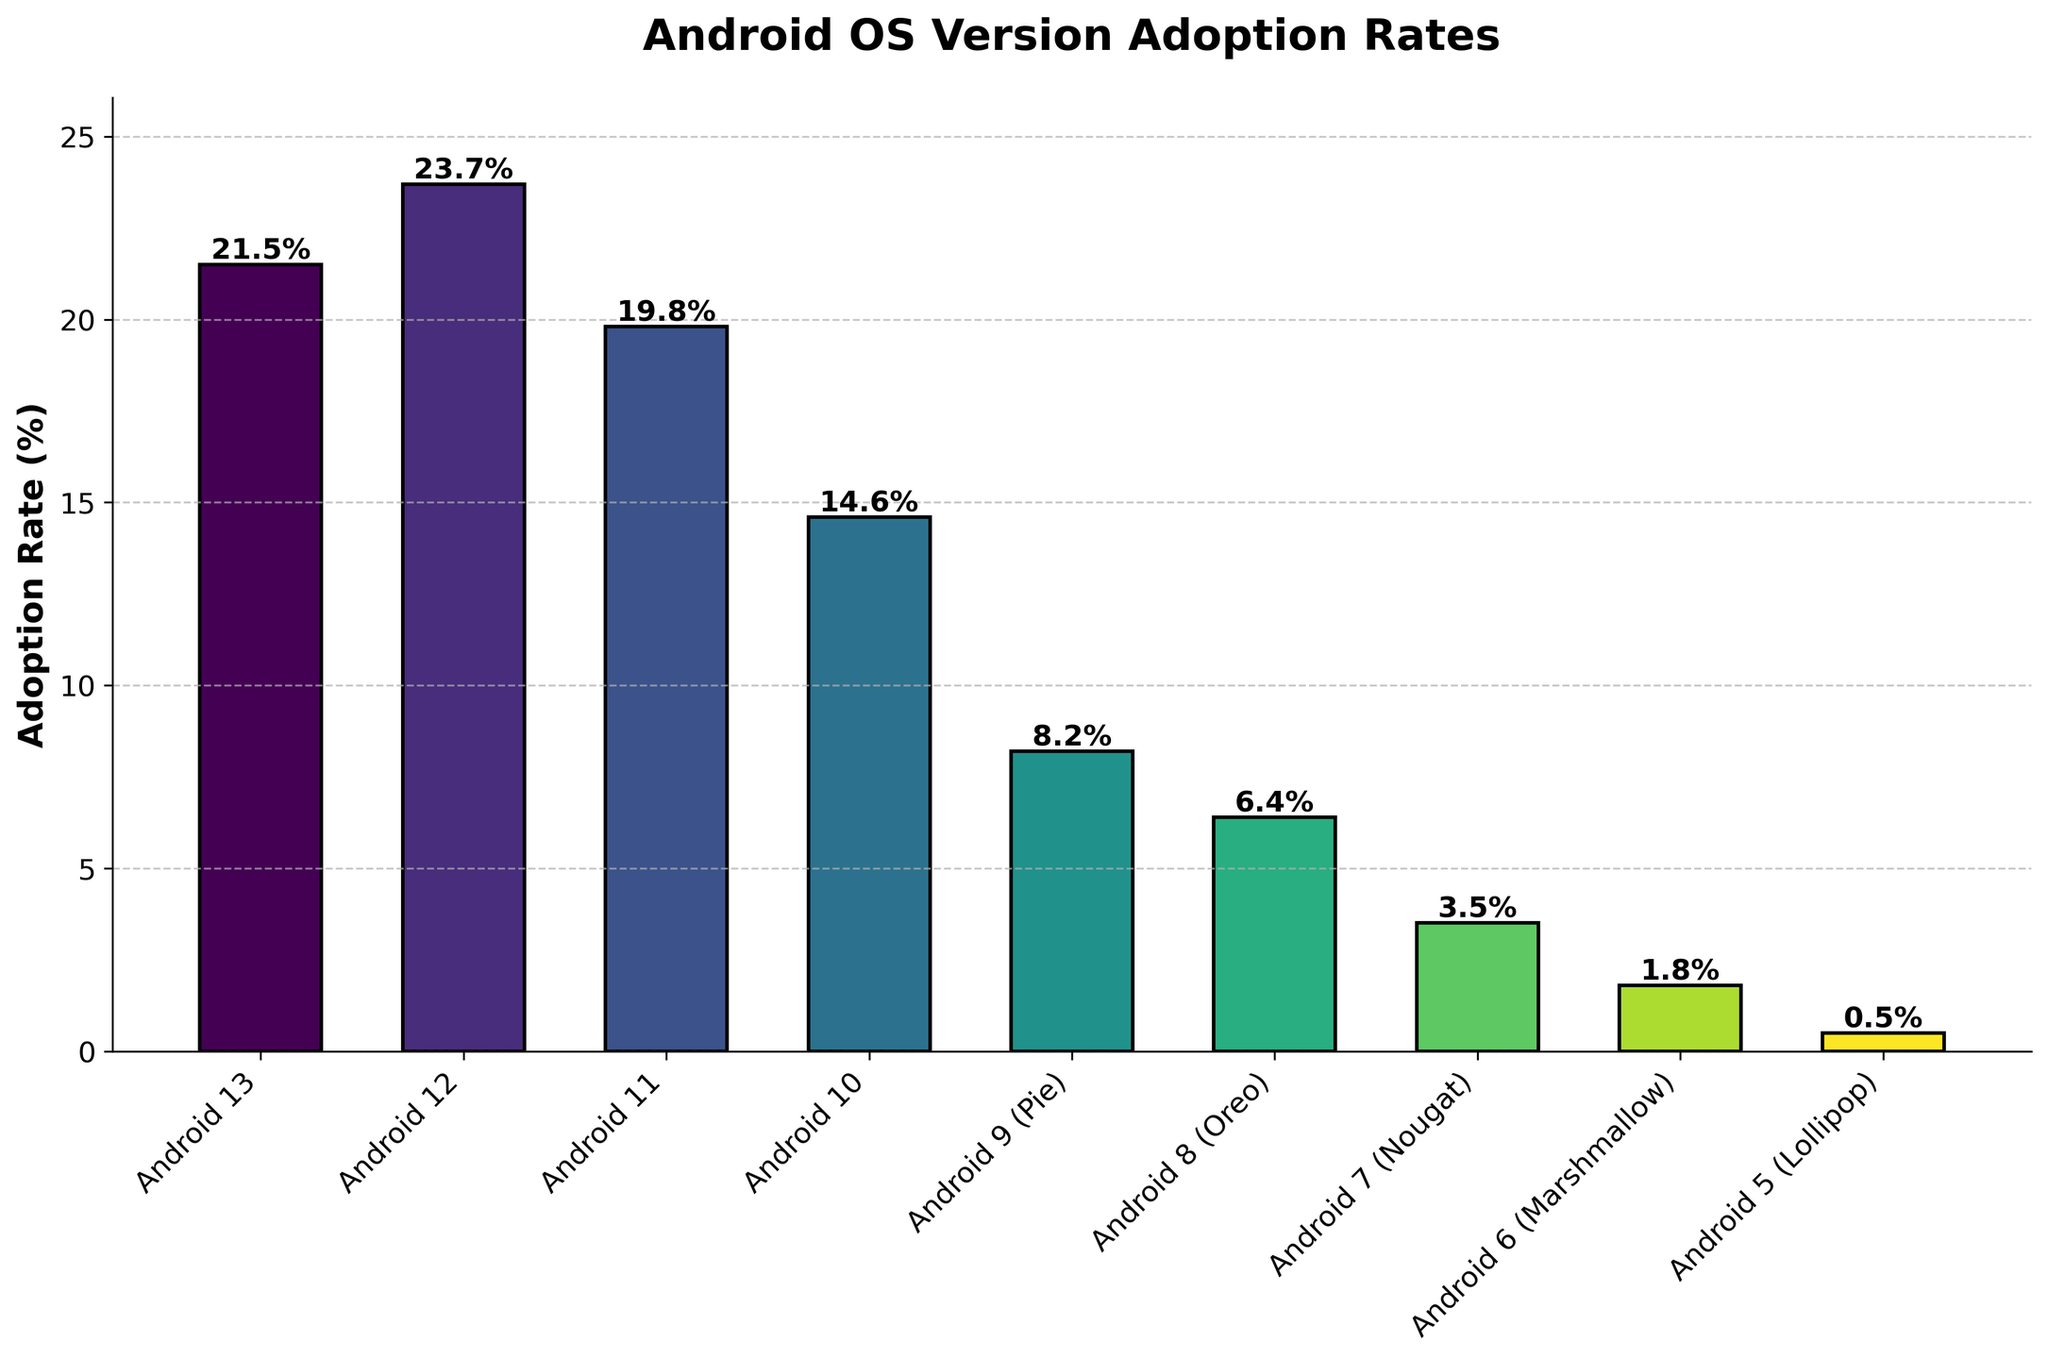Which Android version has the highest adoption rate? The height of each bar represents the adoption rate. The bar for Android 12 is the tallest, indicating the highest adoption rate.
Answer: Android 12 What is the total adoption rate for Android 13 and Android 12 combined? Add the adoption rates of Android 13 (21.5) and Android 12 (23.7). The total is 21.5 + 23.7 = 45.2%.
Answer: 45.2% Which Android versions have an adoption rate less than 5%? Look for bars that are below the 5% threshold. Android 7 (3.5), Android 6 (1.8), and Android 5 (0.5) have adoption rates below 5%.
Answer: Android 7, Android 6, Android 5 How much higher is the adoption rate of Android 11 compared to Android 10? Subtract the adoption rate of Android 10 (14.6) from that of Android 11 (19.8). The difference is 19.8 - 14.6 = 5.2%.
Answer: 5.2% What is the average adoption rate for all Android versions? Add the adoption rates for each version (21.5 + 23.7 + 19.8 + 14.6 + 8.2 + 6.4 + 3.5 + 1.8 + 0.5), and then divide by the number of versions (9). The average is (99/9) = 11%.
Answer: 11% Which Android version has a bar colored towards the end of the color gradient, specifically dark blue or purple? The color gradient moves from light to dark. The bar for Android 5 (Lollipop) is colored in dark blue/purple.
Answer: Android 5 Is the adoption rate of Android 9 greater than the combined rate of Android 7 and Android 6? Android 9 has an adoption rate of 8.2%. Combine the rates for Android 7 (3.5) and Android 6 (1.8), which gives 3.5 + 1.8 = 5.3%. Since 8.2% is greater than 5.3%, the answer is yes.
Answer: Yes If you sum the adoption rates of Android 8, Android 7, and Android 6, how does this compare to the adoption rate of Android 12? Sum the rates for Android 8 (6.4), Android 7 (3.5), and Android 6 (1.8). The total is 6.4 + 3.5 + 1.8 = 11.7%. Compare this to Android 12's rate of 23.7%, which is higher.
Answer: Less than Android 12 